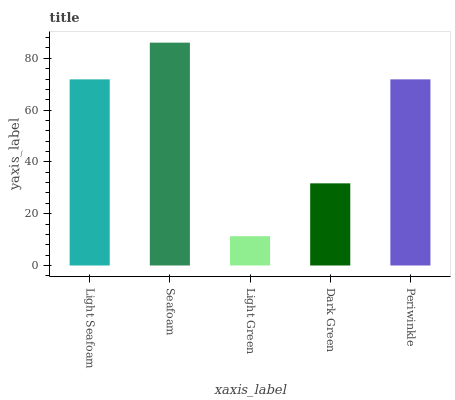Is Light Green the minimum?
Answer yes or no. Yes. Is Seafoam the maximum?
Answer yes or no. Yes. Is Seafoam the minimum?
Answer yes or no. No. Is Light Green the maximum?
Answer yes or no. No. Is Seafoam greater than Light Green?
Answer yes or no. Yes. Is Light Green less than Seafoam?
Answer yes or no. Yes. Is Light Green greater than Seafoam?
Answer yes or no. No. Is Seafoam less than Light Green?
Answer yes or no. No. Is Light Seafoam the high median?
Answer yes or no. Yes. Is Light Seafoam the low median?
Answer yes or no. Yes. Is Light Green the high median?
Answer yes or no. No. Is Periwinkle the low median?
Answer yes or no. No. 